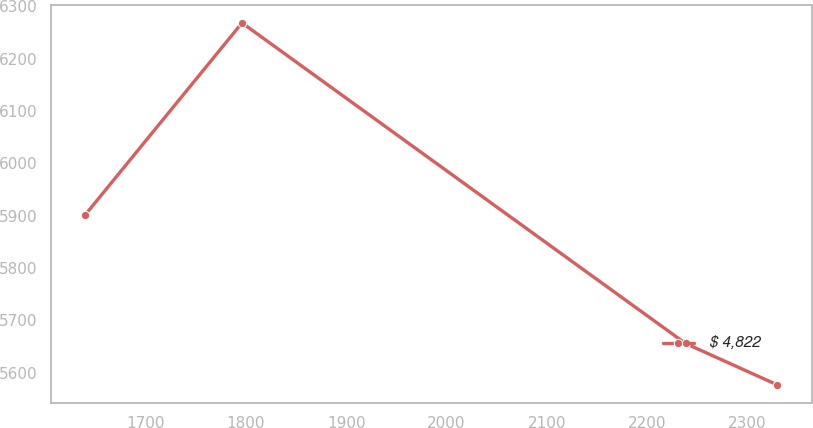Convert chart to OTSL. <chart><loc_0><loc_0><loc_500><loc_500><line_chart><ecel><fcel>$ 4,822<nl><fcel>1640.01<fcel>5901.73<nl><fcel>1796.15<fcel>6268.2<nl><fcel>2238.28<fcel>5655.55<nl><fcel>2329.71<fcel>5576.47<nl></chart> 